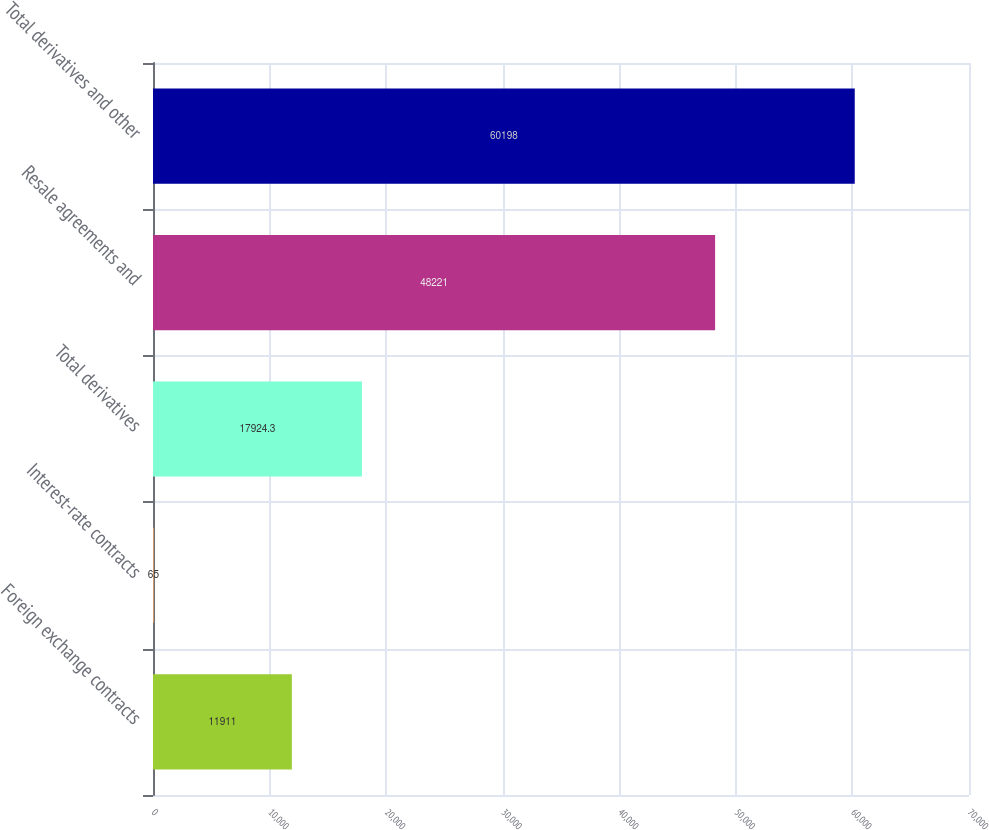Convert chart to OTSL. <chart><loc_0><loc_0><loc_500><loc_500><bar_chart><fcel>Foreign exchange contracts<fcel>Interest-rate contracts<fcel>Total derivatives<fcel>Resale agreements and<fcel>Total derivatives and other<nl><fcel>11911<fcel>65<fcel>17924.3<fcel>48221<fcel>60198<nl></chart> 